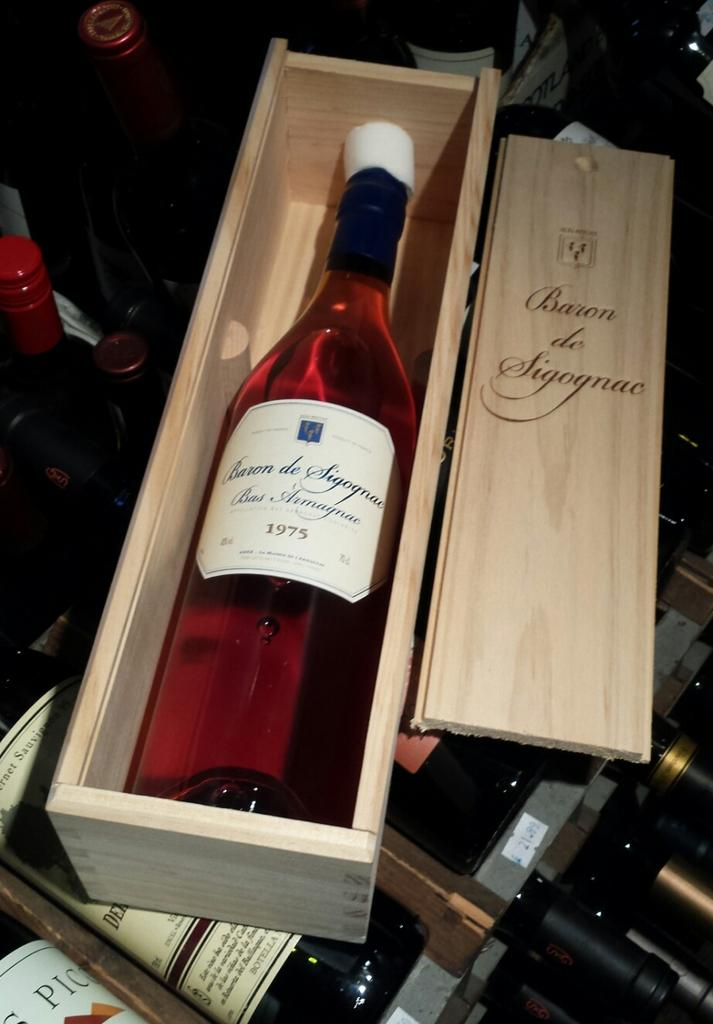Provide a one-sentence caption for the provided image. a bottle of baron de sigognae wine from 1975. 